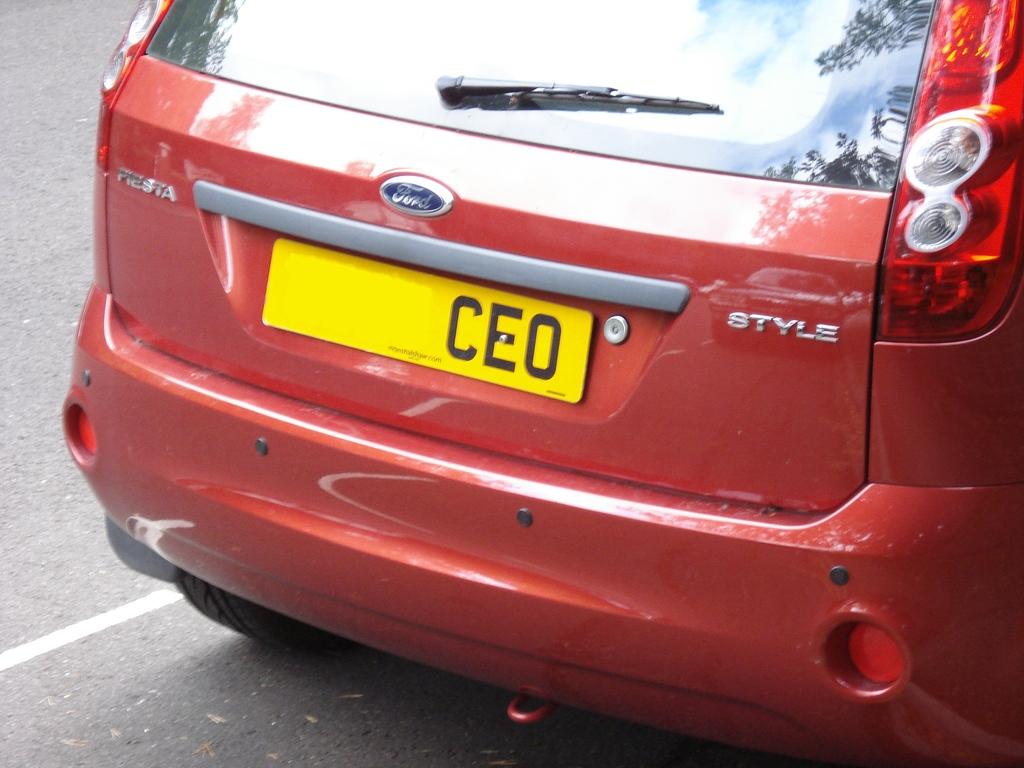What manufacturer built this car?
Offer a terse response. Ford. What is the model of this car?
Make the answer very short. Ford. 